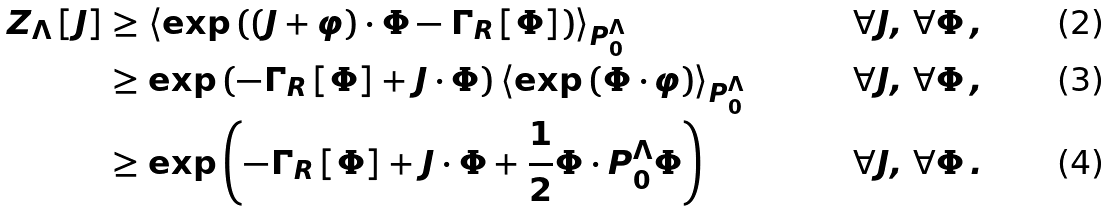Convert formula to latex. <formula><loc_0><loc_0><loc_500><loc_500>Z _ { \Lambda } \left [ J \right ] & \geq \left \langle \exp \left ( \left ( J + \varphi \right ) \cdot \Phi - \Gamma _ { R } \left [ \Phi \right ] \right ) \right \rangle _ { P ^ { \Lambda } _ { 0 } } \quad & \forall J , \, \forall \Phi \, , \\ & \geq \exp \left ( - \Gamma _ { R } \left [ \Phi \right ] + J \cdot \Phi \right ) \left \langle \exp \left ( \Phi \cdot \varphi \right ) \right \rangle _ { P ^ { \Lambda } _ { 0 } } \quad & \forall J , \, \forall \Phi \, , \\ & \geq \exp \left ( - \Gamma _ { R } \left [ \Phi \right ] + J \cdot \Phi + \frac { 1 } { 2 } \Phi \cdot P ^ { \Lambda } _ { 0 } \Phi \right ) \quad & \forall J , \, \forall \Phi \, .</formula> 